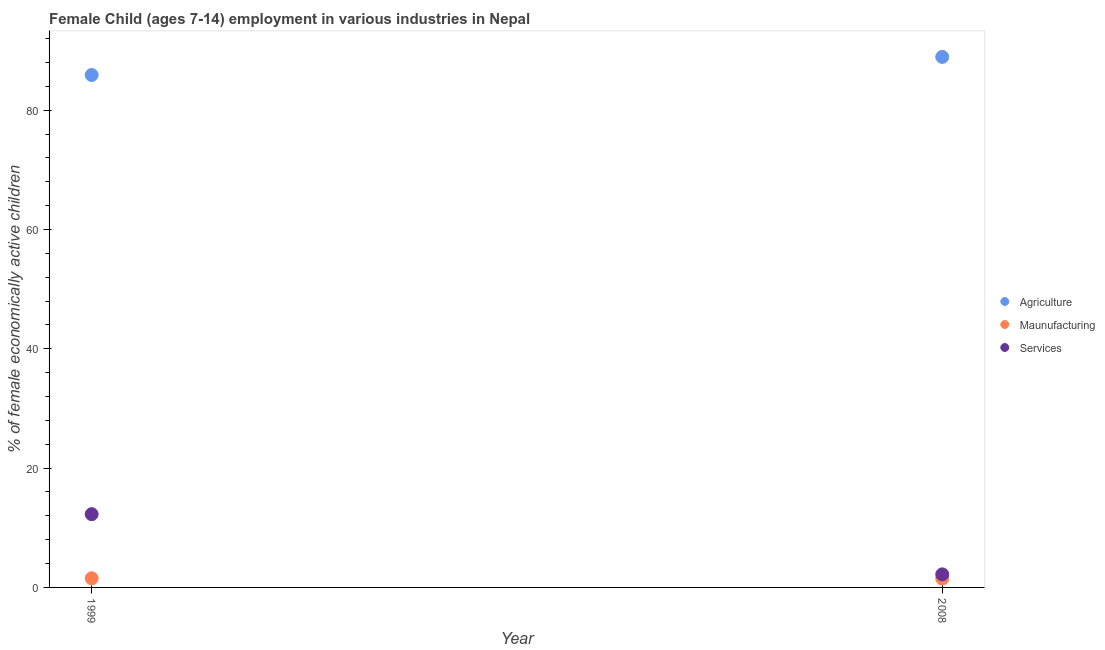How many different coloured dotlines are there?
Your answer should be compact. 3. What is the percentage of economically active children in manufacturing in 2008?
Your answer should be very brief. 1.48. Across all years, what is the maximum percentage of economically active children in agriculture?
Your response must be concise. 88.93. Across all years, what is the minimum percentage of economically active children in agriculture?
Keep it short and to the point. 85.9. What is the total percentage of economically active children in manufacturing in the graph?
Make the answer very short. 3.01. What is the difference between the percentage of economically active children in services in 1999 and that in 2008?
Your answer should be compact. 10.09. What is the difference between the percentage of economically active children in agriculture in 1999 and the percentage of economically active children in manufacturing in 2008?
Give a very brief answer. 84.42. What is the average percentage of economically active children in agriculture per year?
Your response must be concise. 87.42. In the year 1999, what is the difference between the percentage of economically active children in services and percentage of economically active children in agriculture?
Provide a short and direct response. -73.62. In how many years, is the percentage of economically active children in services greater than 24 %?
Your answer should be very brief. 0. What is the ratio of the percentage of economically active children in agriculture in 1999 to that in 2008?
Make the answer very short. 0.97. Is it the case that in every year, the sum of the percentage of economically active children in agriculture and percentage of economically active children in manufacturing is greater than the percentage of economically active children in services?
Your answer should be very brief. Yes. Does the percentage of economically active children in agriculture monotonically increase over the years?
Offer a very short reply. Yes. Is the percentage of economically active children in services strictly less than the percentage of economically active children in agriculture over the years?
Your response must be concise. Yes. How many years are there in the graph?
Offer a very short reply. 2. Are the values on the major ticks of Y-axis written in scientific E-notation?
Provide a short and direct response. No. How many legend labels are there?
Your response must be concise. 3. How are the legend labels stacked?
Provide a short and direct response. Vertical. What is the title of the graph?
Your answer should be very brief. Female Child (ages 7-14) employment in various industries in Nepal. What is the label or title of the X-axis?
Ensure brevity in your answer.  Year. What is the label or title of the Y-axis?
Make the answer very short. % of female economically active children. What is the % of female economically active children in Agriculture in 1999?
Your answer should be very brief. 85.9. What is the % of female economically active children of Maunufacturing in 1999?
Make the answer very short. 1.53. What is the % of female economically active children in Services in 1999?
Offer a terse response. 12.28. What is the % of female economically active children of Agriculture in 2008?
Provide a succinct answer. 88.93. What is the % of female economically active children in Maunufacturing in 2008?
Provide a short and direct response. 1.48. What is the % of female economically active children in Services in 2008?
Keep it short and to the point. 2.19. Across all years, what is the maximum % of female economically active children of Agriculture?
Keep it short and to the point. 88.93. Across all years, what is the maximum % of female economically active children of Maunufacturing?
Keep it short and to the point. 1.53. Across all years, what is the maximum % of female economically active children in Services?
Your answer should be compact. 12.28. Across all years, what is the minimum % of female economically active children of Agriculture?
Your answer should be compact. 85.9. Across all years, what is the minimum % of female economically active children of Maunufacturing?
Keep it short and to the point. 1.48. Across all years, what is the minimum % of female economically active children in Services?
Offer a very short reply. 2.19. What is the total % of female economically active children in Agriculture in the graph?
Offer a very short reply. 174.83. What is the total % of female economically active children of Maunufacturing in the graph?
Ensure brevity in your answer.  3.01. What is the total % of female economically active children in Services in the graph?
Make the answer very short. 14.47. What is the difference between the % of female economically active children of Agriculture in 1999 and that in 2008?
Make the answer very short. -3.03. What is the difference between the % of female economically active children in Maunufacturing in 1999 and that in 2008?
Make the answer very short. 0.05. What is the difference between the % of female economically active children in Services in 1999 and that in 2008?
Provide a short and direct response. 10.09. What is the difference between the % of female economically active children in Agriculture in 1999 and the % of female economically active children in Maunufacturing in 2008?
Keep it short and to the point. 84.42. What is the difference between the % of female economically active children of Agriculture in 1999 and the % of female economically active children of Services in 2008?
Ensure brevity in your answer.  83.71. What is the difference between the % of female economically active children of Maunufacturing in 1999 and the % of female economically active children of Services in 2008?
Ensure brevity in your answer.  -0.66. What is the average % of female economically active children of Agriculture per year?
Make the answer very short. 87.42. What is the average % of female economically active children of Maunufacturing per year?
Offer a terse response. 1.51. What is the average % of female economically active children of Services per year?
Your answer should be very brief. 7.24. In the year 1999, what is the difference between the % of female economically active children in Agriculture and % of female economically active children in Maunufacturing?
Ensure brevity in your answer.  84.37. In the year 1999, what is the difference between the % of female economically active children of Agriculture and % of female economically active children of Services?
Offer a terse response. 73.62. In the year 1999, what is the difference between the % of female economically active children of Maunufacturing and % of female economically active children of Services?
Give a very brief answer. -10.75. In the year 2008, what is the difference between the % of female economically active children of Agriculture and % of female economically active children of Maunufacturing?
Give a very brief answer. 87.45. In the year 2008, what is the difference between the % of female economically active children of Agriculture and % of female economically active children of Services?
Provide a succinct answer. 86.74. In the year 2008, what is the difference between the % of female economically active children in Maunufacturing and % of female economically active children in Services?
Offer a very short reply. -0.71. What is the ratio of the % of female economically active children of Agriculture in 1999 to that in 2008?
Offer a terse response. 0.97. What is the ratio of the % of female economically active children of Maunufacturing in 1999 to that in 2008?
Keep it short and to the point. 1.03. What is the ratio of the % of female economically active children of Services in 1999 to that in 2008?
Offer a very short reply. 5.61. What is the difference between the highest and the second highest % of female economically active children in Agriculture?
Provide a succinct answer. 3.03. What is the difference between the highest and the second highest % of female economically active children of Maunufacturing?
Your response must be concise. 0.05. What is the difference between the highest and the second highest % of female economically active children in Services?
Make the answer very short. 10.09. What is the difference between the highest and the lowest % of female economically active children in Agriculture?
Offer a terse response. 3.03. What is the difference between the highest and the lowest % of female economically active children in Maunufacturing?
Offer a very short reply. 0.05. What is the difference between the highest and the lowest % of female economically active children of Services?
Offer a terse response. 10.09. 